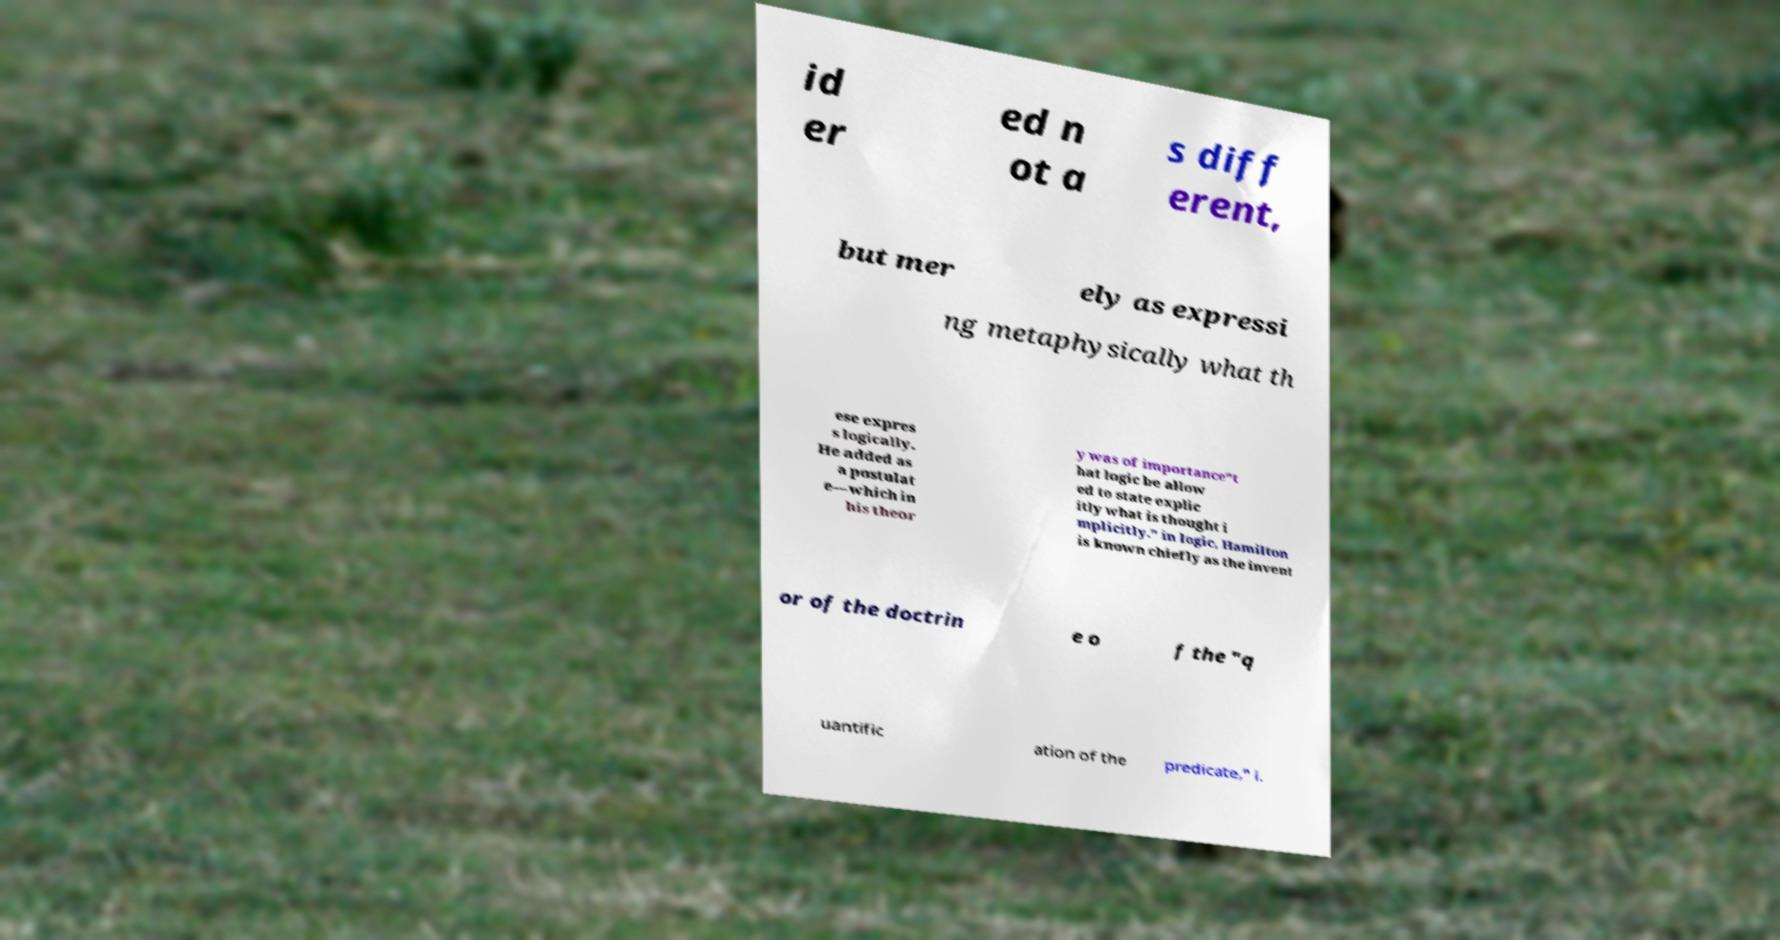For documentation purposes, I need the text within this image transcribed. Could you provide that? id er ed n ot a s diff erent, but mer ely as expressi ng metaphysically what th ese expres s logically. He added as a postulat e—which in his theor y was of importance"t hat logic be allow ed to state explic itly what is thought i mplicitly." in logic, Hamilton is known chiefly as the invent or of the doctrin e o f the "q uantific ation of the predicate," i. 